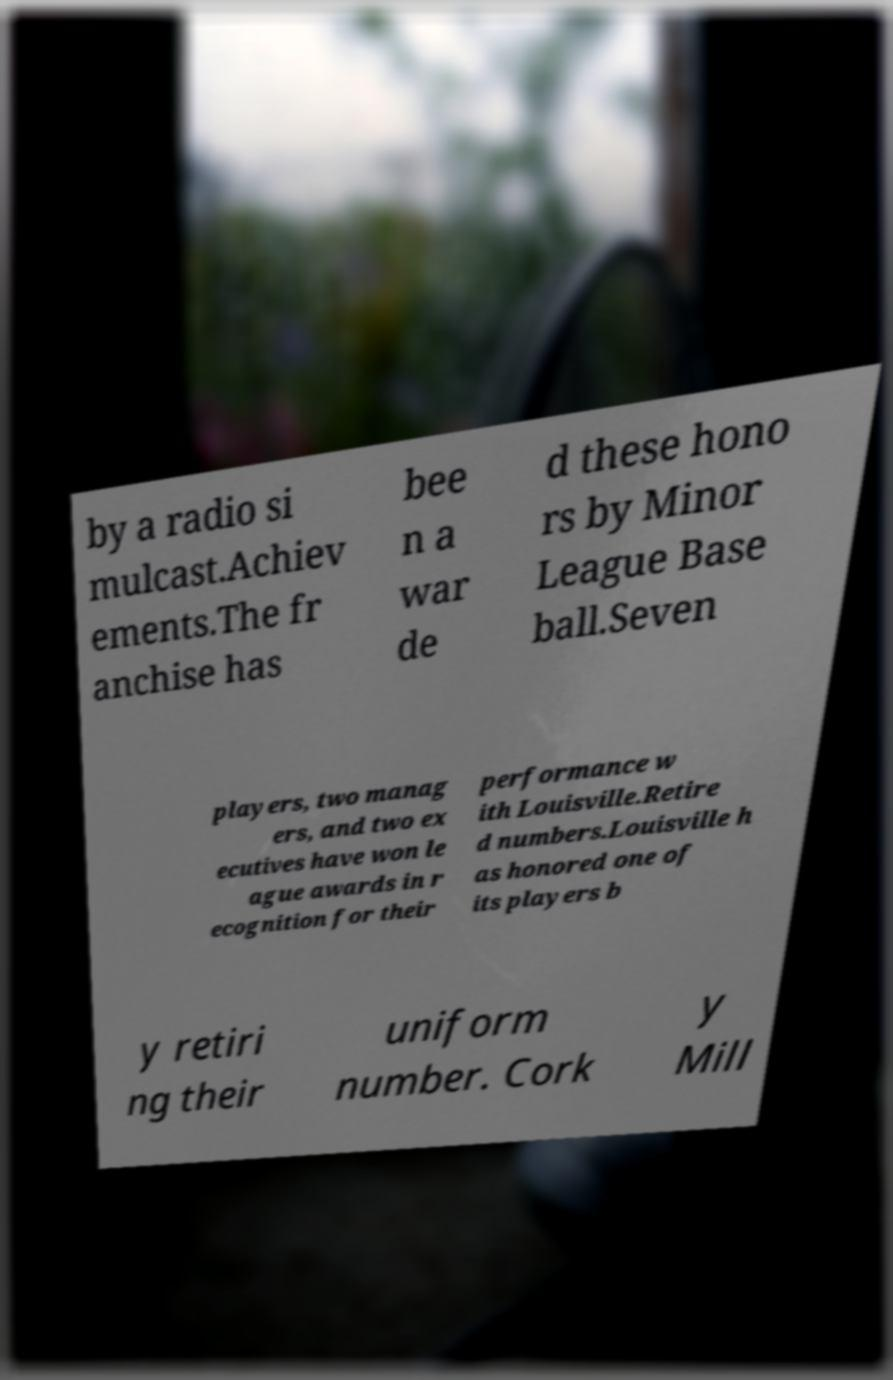Can you read and provide the text displayed in the image?This photo seems to have some interesting text. Can you extract and type it out for me? by a radio si mulcast.Achiev ements.The fr anchise has bee n a war de d these hono rs by Minor League Base ball.Seven players, two manag ers, and two ex ecutives have won le ague awards in r ecognition for their performance w ith Louisville.Retire d numbers.Louisville h as honored one of its players b y retiri ng their uniform number. Cork y Mill 